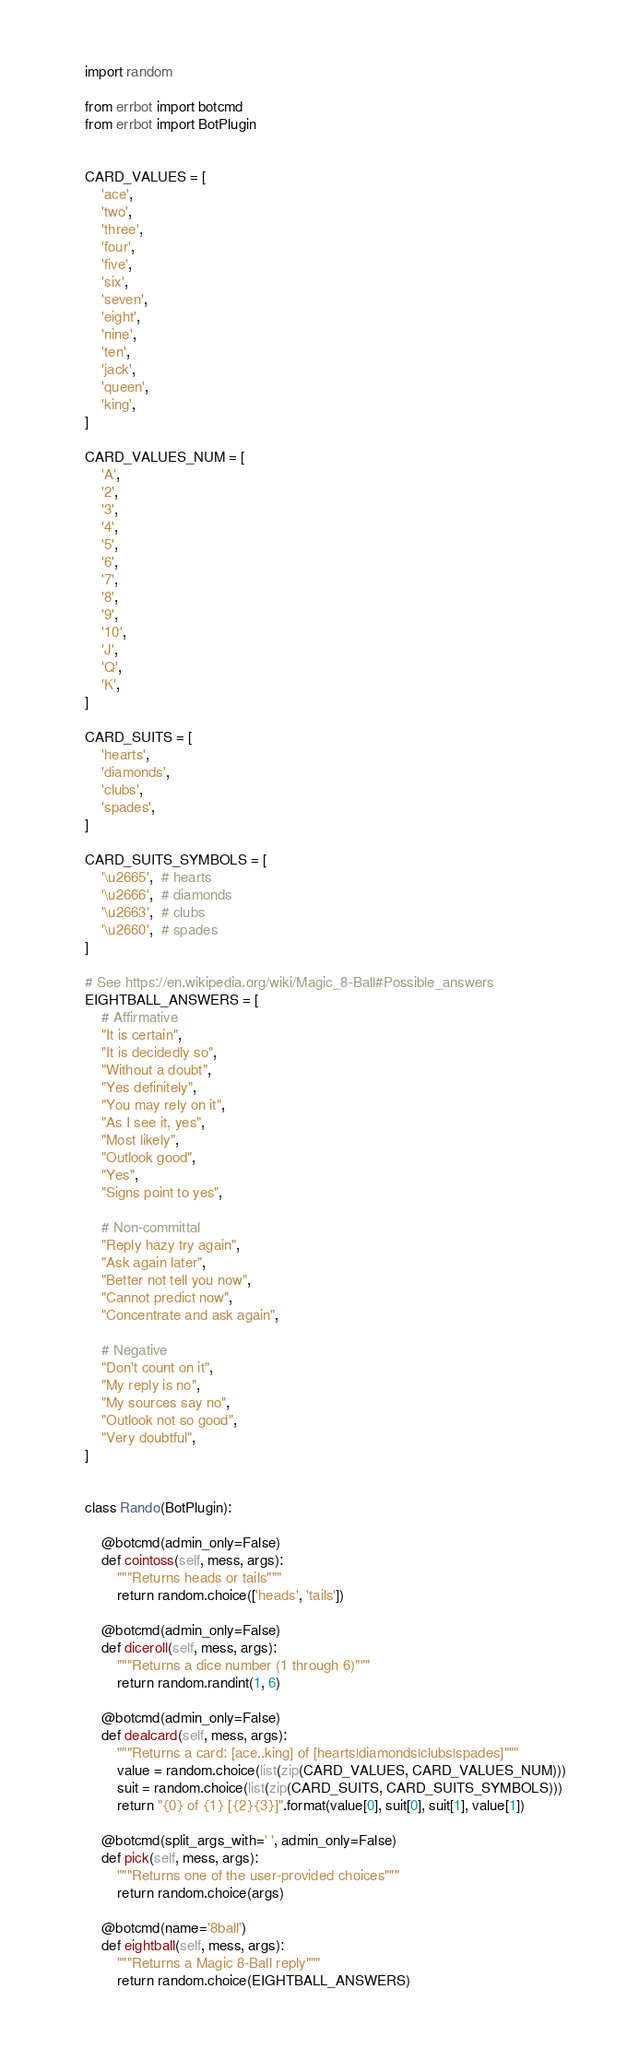<code> <loc_0><loc_0><loc_500><loc_500><_Python_>import random

from errbot import botcmd
from errbot import BotPlugin


CARD_VALUES = [
    'ace',
    'two',
    'three',
    'four',
    'five',
    'six',
    'seven',
    'eight',
    'nine',
    'ten',
    'jack',
    'queen',
    'king',
]

CARD_VALUES_NUM = [
    'A',
    '2',
    '3',
    '4',
    '5',
    '6',
    '7',
    '8',
    '9',
    '10',
    'J',
    'Q',
    'K',
]

CARD_SUITS = [
    'hearts',
    'diamonds',
    'clubs',
    'spades',
]

CARD_SUITS_SYMBOLS = [
    '\u2665',  # hearts
    '\u2666',  # diamonds
    '\u2663',  # clubs
    '\u2660',  # spades
]

# See https://en.wikipedia.org/wiki/Magic_8-Ball#Possible_answers
EIGHTBALL_ANSWERS = [
    # Affirmative
    "It is certain",
    "It is decidedly so",
    "Without a doubt",
    "Yes definitely",
    "You may rely on it",
    "As I see it, yes",
    "Most likely",
    "Outlook good",
    "Yes",
    "Signs point to yes",

    # Non-committal
    "Reply hazy try again",
    "Ask again later",
    "Better not tell you now",
    "Cannot predict now",
    "Concentrate and ask again",

    # Negative
    "Don't count on it",
    "My reply is no",
    "My sources say no",
    "Outlook not so good",
    "Very doubtful",
]


class Rando(BotPlugin):

    @botcmd(admin_only=False)
    def cointoss(self, mess, args):
        """Returns heads or tails"""
        return random.choice(['heads', 'tails'])

    @botcmd(admin_only=False)
    def diceroll(self, mess, args):
        """Returns a dice number (1 through 6)"""
        return random.randint(1, 6)

    @botcmd(admin_only=False)
    def dealcard(self, mess, args):
        """Returns a card: [ace..king] of [hearts|diamonds|clubs|spades]"""
        value = random.choice(list(zip(CARD_VALUES, CARD_VALUES_NUM)))
        suit = random.choice(list(zip(CARD_SUITS, CARD_SUITS_SYMBOLS)))
        return "{0} of {1} [{2}{3}]".format(value[0], suit[0], suit[1], value[1])

    @botcmd(split_args_with=' ', admin_only=False)
    def pick(self, mess, args):
        """Returns one of the user-provided choices"""
        return random.choice(args)

    @botcmd(name='8ball')
    def eightball(self, mess, args):
        """Returns a Magic 8-Ball reply"""
        return random.choice(EIGHTBALL_ANSWERS)
</code> 